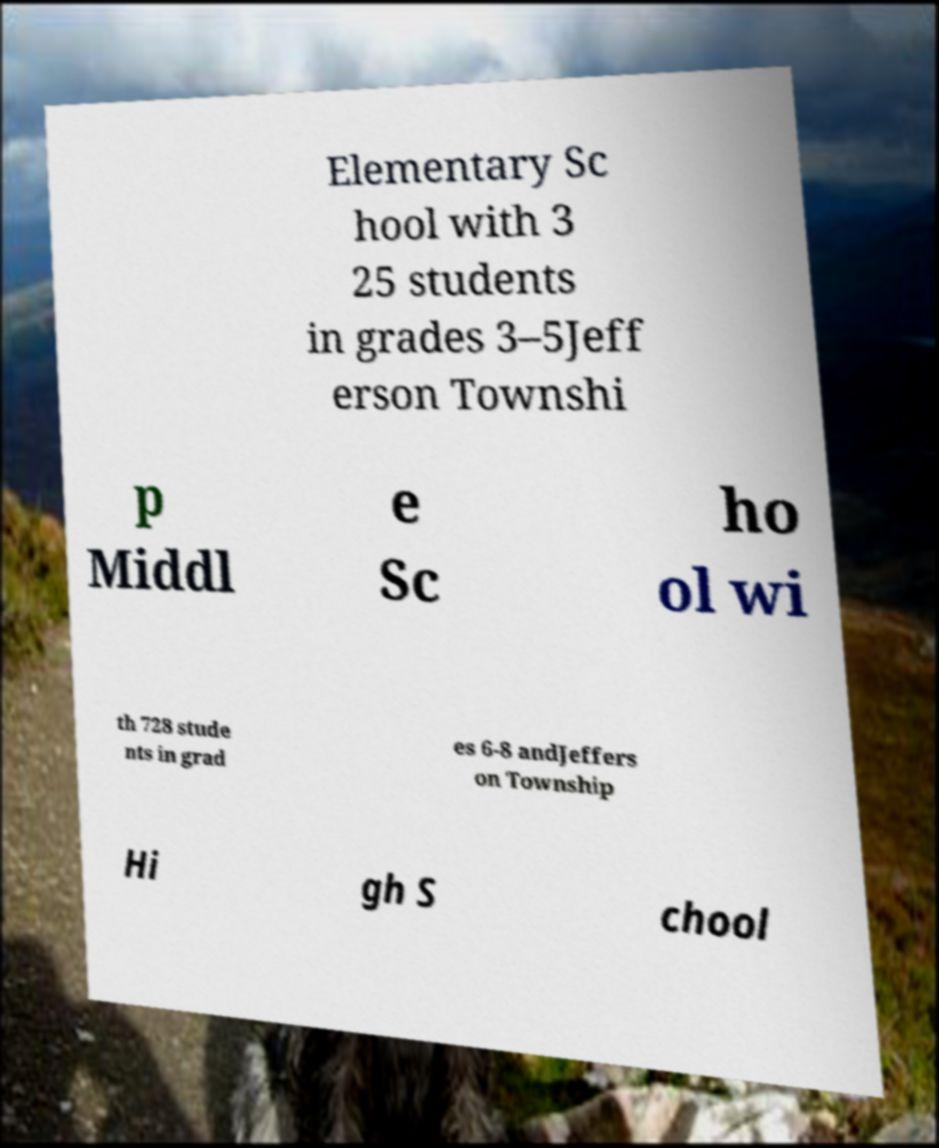Can you accurately transcribe the text from the provided image for me? Elementary Sc hool with 3 25 students in grades 3–5Jeff erson Townshi p Middl e Sc ho ol wi th 728 stude nts in grad es 6-8 andJeffers on Township Hi gh S chool 